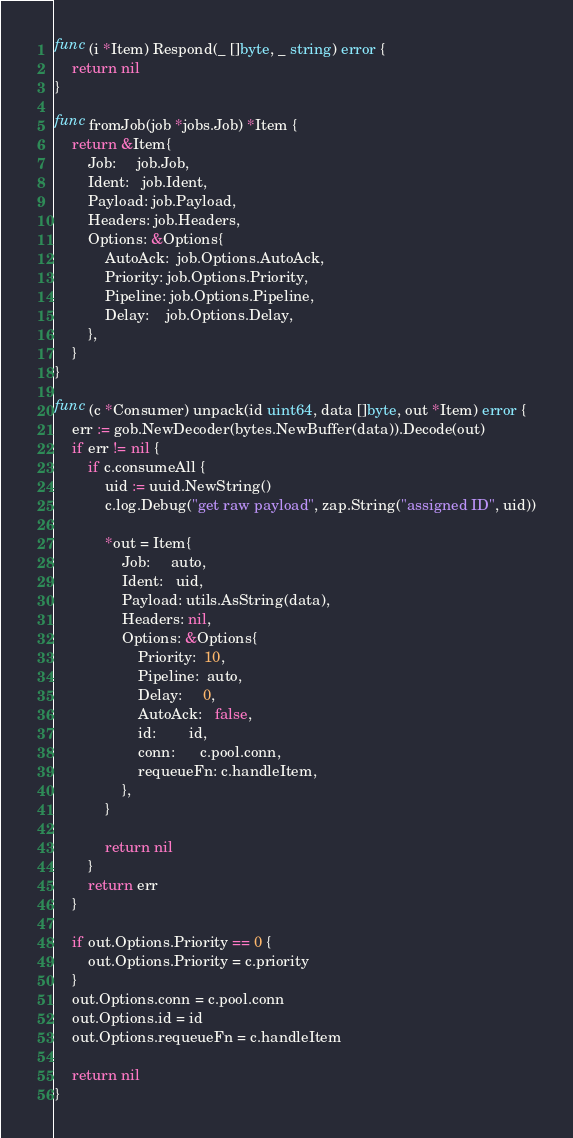<code> <loc_0><loc_0><loc_500><loc_500><_Go_>func (i *Item) Respond(_ []byte, _ string) error {
	return nil
}

func fromJob(job *jobs.Job) *Item {
	return &Item{
		Job:     job.Job,
		Ident:   job.Ident,
		Payload: job.Payload,
		Headers: job.Headers,
		Options: &Options{
			AutoAck:  job.Options.AutoAck,
			Priority: job.Options.Priority,
			Pipeline: job.Options.Pipeline,
			Delay:    job.Options.Delay,
		},
	}
}

func (c *Consumer) unpack(id uint64, data []byte, out *Item) error {
	err := gob.NewDecoder(bytes.NewBuffer(data)).Decode(out)
	if err != nil {
		if c.consumeAll {
			uid := uuid.NewString()
			c.log.Debug("get raw payload", zap.String("assigned ID", uid))

			*out = Item{
				Job:     auto,
				Ident:   uid,
				Payload: utils.AsString(data),
				Headers: nil,
				Options: &Options{
					Priority:  10,
					Pipeline:  auto,
					Delay:     0,
					AutoAck:   false,
					id:        id,
					conn:      c.pool.conn,
					requeueFn: c.handleItem,
				},
			}

			return nil
		}
		return err
	}

	if out.Options.Priority == 0 {
		out.Options.Priority = c.priority
	}
	out.Options.conn = c.pool.conn
	out.Options.id = id
	out.Options.requeueFn = c.handleItem

	return nil
}
</code> 